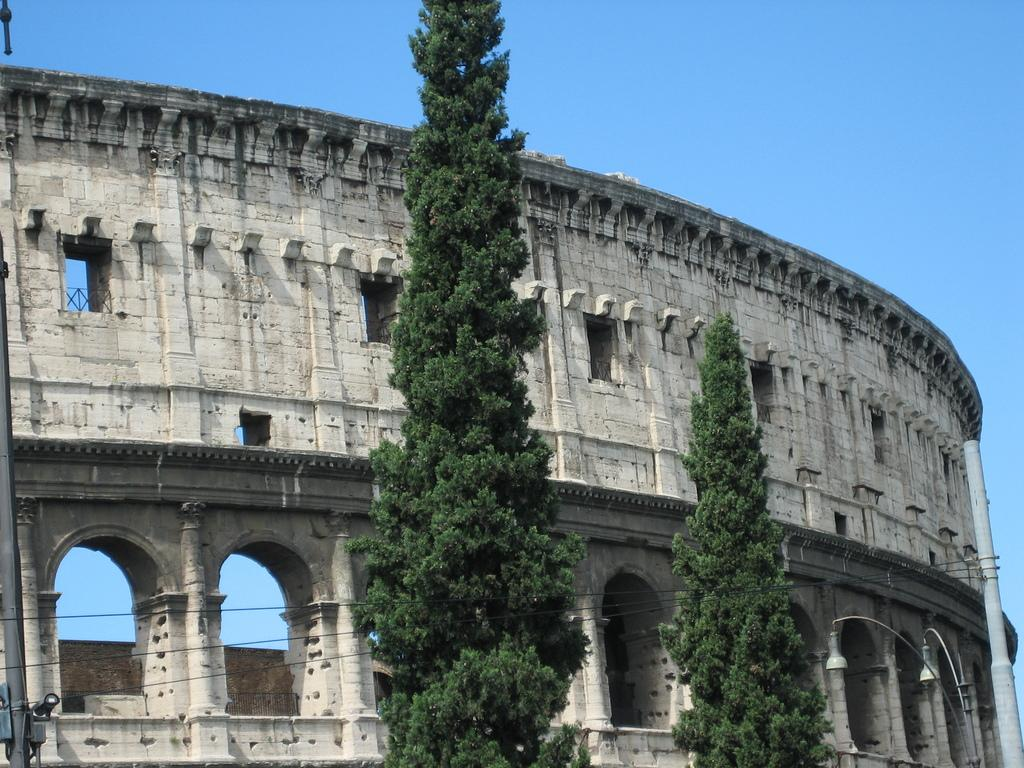What type of structure is featured in the image? There is a building with a group of arches in the image. What can be seen in the foreground of the image? There are two trees and a pole in the foreground of the image. What is visible in the background of the image? The sky is visible in the background of the image. How many cats are climbing up the pole in the image? There are no cats present in the image; it only features a building, trees, a pole, and the sky. 